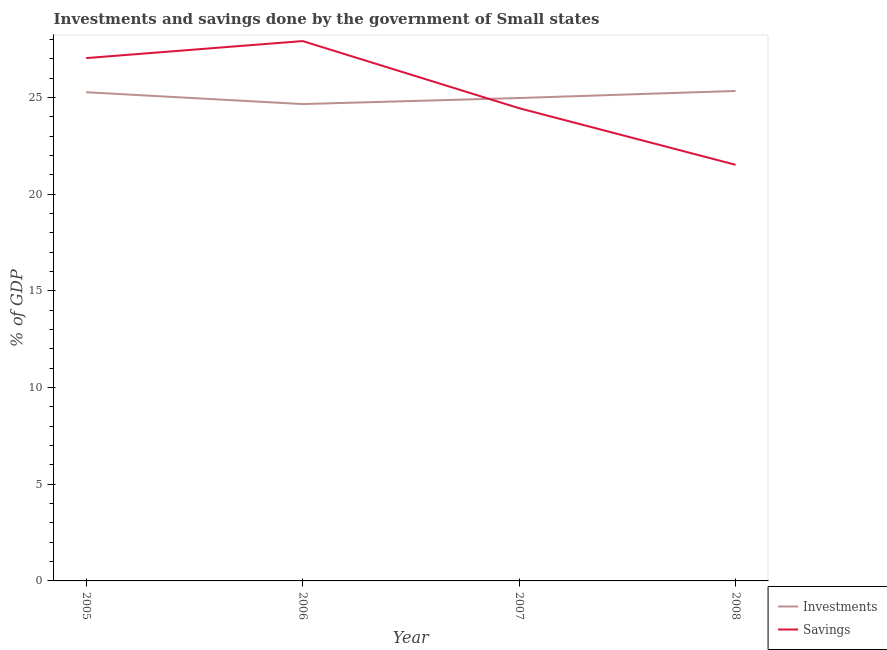How many different coloured lines are there?
Your answer should be very brief. 2. Does the line corresponding to savings of government intersect with the line corresponding to investments of government?
Provide a succinct answer. Yes. What is the investments of government in 2007?
Provide a short and direct response. 24.97. Across all years, what is the maximum savings of government?
Offer a very short reply. 27.92. Across all years, what is the minimum savings of government?
Offer a very short reply. 21.52. In which year was the investments of government maximum?
Offer a terse response. 2008. In which year was the investments of government minimum?
Provide a short and direct response. 2006. What is the total savings of government in the graph?
Give a very brief answer. 100.91. What is the difference between the savings of government in 2005 and that in 2006?
Provide a succinct answer. -0.88. What is the difference between the investments of government in 2005 and the savings of government in 2007?
Give a very brief answer. 0.83. What is the average savings of government per year?
Ensure brevity in your answer.  25.23. In the year 2006, what is the difference between the investments of government and savings of government?
Your answer should be very brief. -3.26. What is the ratio of the investments of government in 2005 to that in 2008?
Your response must be concise. 1. What is the difference between the highest and the second highest savings of government?
Provide a succinct answer. 0.88. What is the difference between the highest and the lowest savings of government?
Keep it short and to the point. 6.4. Is the investments of government strictly greater than the savings of government over the years?
Your answer should be compact. No. How many lines are there?
Ensure brevity in your answer.  2. Are the values on the major ticks of Y-axis written in scientific E-notation?
Make the answer very short. No. Does the graph contain any zero values?
Offer a terse response. No. Does the graph contain grids?
Make the answer very short. No. How many legend labels are there?
Your response must be concise. 2. How are the legend labels stacked?
Offer a terse response. Vertical. What is the title of the graph?
Your response must be concise. Investments and savings done by the government of Small states. What is the label or title of the Y-axis?
Give a very brief answer. % of GDP. What is the % of GDP in Investments in 2005?
Give a very brief answer. 25.27. What is the % of GDP of Savings in 2005?
Your answer should be compact. 27.04. What is the % of GDP in Investments in 2006?
Your response must be concise. 24.66. What is the % of GDP of Savings in 2006?
Keep it short and to the point. 27.92. What is the % of GDP in Investments in 2007?
Provide a short and direct response. 24.97. What is the % of GDP in Savings in 2007?
Make the answer very short. 24.44. What is the % of GDP in Investments in 2008?
Offer a terse response. 25.34. What is the % of GDP in Savings in 2008?
Keep it short and to the point. 21.52. Across all years, what is the maximum % of GDP in Investments?
Your answer should be very brief. 25.34. Across all years, what is the maximum % of GDP in Savings?
Offer a very short reply. 27.92. Across all years, what is the minimum % of GDP in Investments?
Your response must be concise. 24.66. Across all years, what is the minimum % of GDP of Savings?
Make the answer very short. 21.52. What is the total % of GDP in Investments in the graph?
Give a very brief answer. 100.24. What is the total % of GDP in Savings in the graph?
Your answer should be compact. 100.91. What is the difference between the % of GDP of Investments in 2005 and that in 2006?
Your response must be concise. 0.61. What is the difference between the % of GDP of Savings in 2005 and that in 2006?
Ensure brevity in your answer.  -0.88. What is the difference between the % of GDP of Investments in 2005 and that in 2007?
Provide a short and direct response. 0.3. What is the difference between the % of GDP in Savings in 2005 and that in 2007?
Provide a short and direct response. 2.59. What is the difference between the % of GDP of Investments in 2005 and that in 2008?
Provide a succinct answer. -0.07. What is the difference between the % of GDP of Savings in 2005 and that in 2008?
Provide a succinct answer. 5.52. What is the difference between the % of GDP of Investments in 2006 and that in 2007?
Provide a succinct answer. -0.31. What is the difference between the % of GDP of Savings in 2006 and that in 2007?
Your response must be concise. 3.47. What is the difference between the % of GDP in Investments in 2006 and that in 2008?
Ensure brevity in your answer.  -0.68. What is the difference between the % of GDP of Savings in 2006 and that in 2008?
Ensure brevity in your answer.  6.4. What is the difference between the % of GDP of Investments in 2007 and that in 2008?
Provide a succinct answer. -0.37. What is the difference between the % of GDP of Savings in 2007 and that in 2008?
Ensure brevity in your answer.  2.93. What is the difference between the % of GDP of Investments in 2005 and the % of GDP of Savings in 2006?
Offer a terse response. -2.65. What is the difference between the % of GDP of Investments in 2005 and the % of GDP of Savings in 2007?
Ensure brevity in your answer.  0.83. What is the difference between the % of GDP of Investments in 2005 and the % of GDP of Savings in 2008?
Your answer should be very brief. 3.75. What is the difference between the % of GDP in Investments in 2006 and the % of GDP in Savings in 2007?
Your response must be concise. 0.21. What is the difference between the % of GDP in Investments in 2006 and the % of GDP in Savings in 2008?
Provide a succinct answer. 3.14. What is the difference between the % of GDP of Investments in 2007 and the % of GDP of Savings in 2008?
Offer a very short reply. 3.45. What is the average % of GDP of Investments per year?
Your response must be concise. 25.06. What is the average % of GDP in Savings per year?
Keep it short and to the point. 25.23. In the year 2005, what is the difference between the % of GDP of Investments and % of GDP of Savings?
Provide a succinct answer. -1.77. In the year 2006, what is the difference between the % of GDP in Investments and % of GDP in Savings?
Keep it short and to the point. -3.26. In the year 2007, what is the difference between the % of GDP in Investments and % of GDP in Savings?
Keep it short and to the point. 0.53. In the year 2008, what is the difference between the % of GDP of Investments and % of GDP of Savings?
Keep it short and to the point. 3.82. What is the ratio of the % of GDP of Investments in 2005 to that in 2006?
Make the answer very short. 1.02. What is the ratio of the % of GDP in Savings in 2005 to that in 2006?
Ensure brevity in your answer.  0.97. What is the ratio of the % of GDP in Savings in 2005 to that in 2007?
Make the answer very short. 1.11. What is the ratio of the % of GDP of Investments in 2005 to that in 2008?
Offer a very short reply. 1. What is the ratio of the % of GDP of Savings in 2005 to that in 2008?
Provide a succinct answer. 1.26. What is the ratio of the % of GDP in Investments in 2006 to that in 2007?
Offer a terse response. 0.99. What is the ratio of the % of GDP of Savings in 2006 to that in 2007?
Provide a short and direct response. 1.14. What is the ratio of the % of GDP of Investments in 2006 to that in 2008?
Offer a very short reply. 0.97. What is the ratio of the % of GDP in Savings in 2006 to that in 2008?
Keep it short and to the point. 1.3. What is the ratio of the % of GDP in Investments in 2007 to that in 2008?
Your answer should be compact. 0.99. What is the ratio of the % of GDP of Savings in 2007 to that in 2008?
Your answer should be compact. 1.14. What is the difference between the highest and the second highest % of GDP in Investments?
Keep it short and to the point. 0.07. What is the difference between the highest and the second highest % of GDP in Savings?
Give a very brief answer. 0.88. What is the difference between the highest and the lowest % of GDP in Investments?
Give a very brief answer. 0.68. What is the difference between the highest and the lowest % of GDP in Savings?
Give a very brief answer. 6.4. 